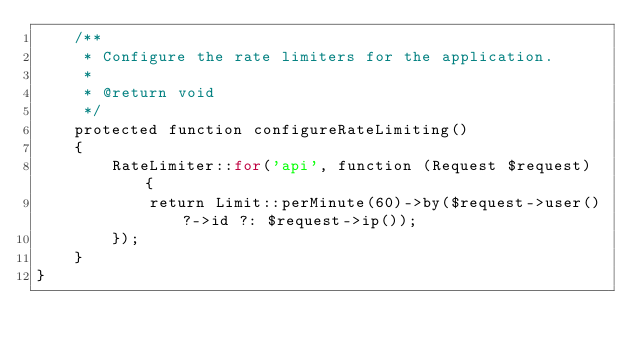<code> <loc_0><loc_0><loc_500><loc_500><_PHP_>    /**
     * Configure the rate limiters for the application.
     *
     * @return void
     */
    protected function configureRateLimiting()
    {
        RateLimiter::for('api', function (Request $request) {
            return Limit::perMinute(60)->by($request->user()?->id ?: $request->ip());
        });
    }
}
</code> 